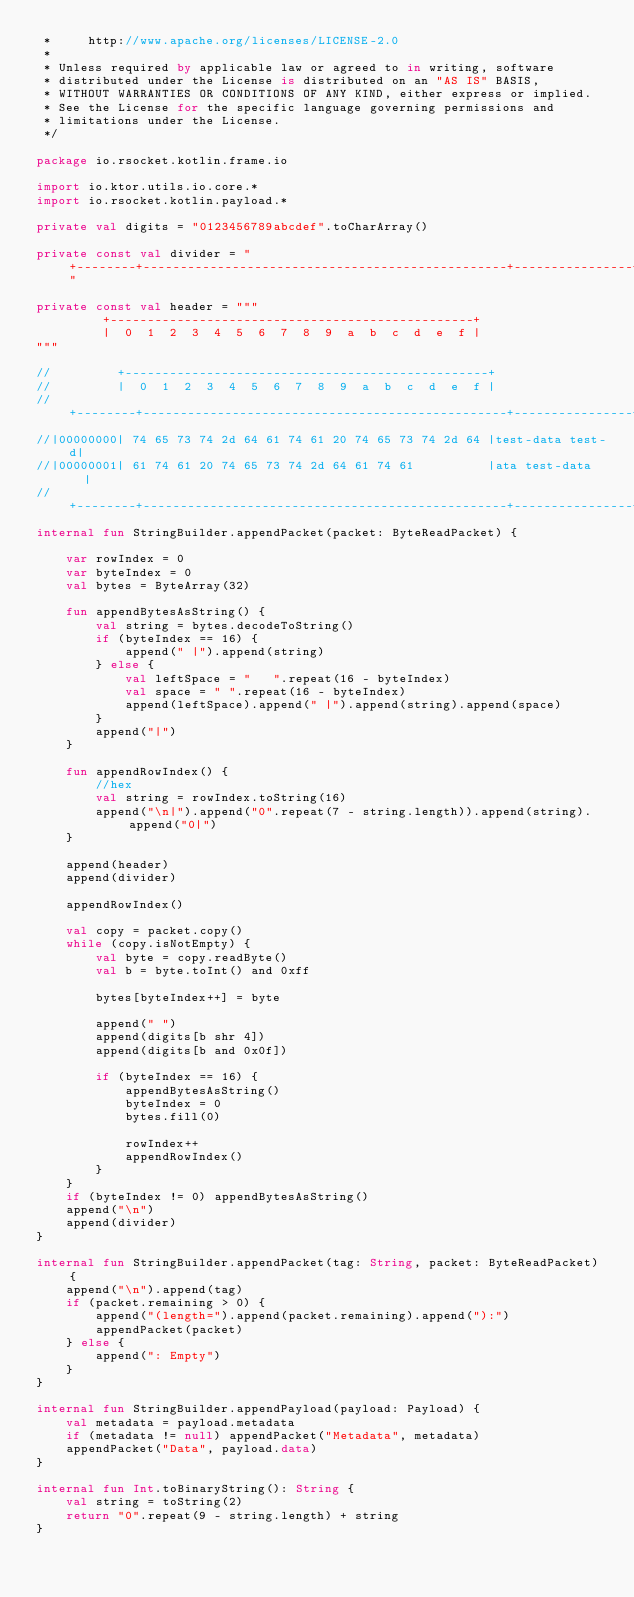Convert code to text. <code><loc_0><loc_0><loc_500><loc_500><_Kotlin_> *     http://www.apache.org/licenses/LICENSE-2.0
 *
 * Unless required by applicable law or agreed to in writing, software
 * distributed under the License is distributed on an "AS IS" BASIS,
 * WITHOUT WARRANTIES OR CONDITIONS OF ANY KIND, either express or implied.
 * See the License for the specific language governing permissions and
 * limitations under the License.
 */

package io.rsocket.kotlin.frame.io

import io.ktor.utils.io.core.*
import io.rsocket.kotlin.payload.*

private val digits = "0123456789abcdef".toCharArray()

private const val divider = "+--------+-------------------------------------------------+----------------+"

private const val header = """
         +-------------------------------------------------+
         |  0  1  2  3  4  5  6  7  8  9  a  b  c  d  e  f |
"""

//         +-------------------------------------------------+
//         |  0  1  2  3  4  5  6  7  8  9  a  b  c  d  e  f |
//+--------+-------------------------------------------------+----------------+
//|00000000| 74 65 73 74 2d 64 61 74 61 20 74 65 73 74 2d 64 |test-data test-d|
//|00000001| 61 74 61 20 74 65 73 74 2d 64 61 74 61          |ata test-data   |
//+--------+-------------------------------------------------+----------------+
internal fun StringBuilder.appendPacket(packet: ByteReadPacket) {

    var rowIndex = 0
    var byteIndex = 0
    val bytes = ByteArray(32)

    fun appendBytesAsString() {
        val string = bytes.decodeToString()
        if (byteIndex == 16) {
            append(" |").append(string)
        } else {
            val leftSpace = "   ".repeat(16 - byteIndex)
            val space = " ".repeat(16 - byteIndex)
            append(leftSpace).append(" |").append(string).append(space)
        }
        append("|")
    }

    fun appendRowIndex() {
        //hex
        val string = rowIndex.toString(16)
        append("\n|").append("0".repeat(7 - string.length)).append(string).append("0|")
    }

    append(header)
    append(divider)

    appendRowIndex()

    val copy = packet.copy()
    while (copy.isNotEmpty) {
        val byte = copy.readByte()
        val b = byte.toInt() and 0xff

        bytes[byteIndex++] = byte

        append(" ")
        append(digits[b shr 4])
        append(digits[b and 0x0f])

        if (byteIndex == 16) {
            appendBytesAsString()
            byteIndex = 0
            bytes.fill(0)

            rowIndex++
            appendRowIndex()
        }
    }
    if (byteIndex != 0) appendBytesAsString()
    append("\n")
    append(divider)
}

internal fun StringBuilder.appendPacket(tag: String, packet: ByteReadPacket) {
    append("\n").append(tag)
    if (packet.remaining > 0) {
        append("(length=").append(packet.remaining).append("):")
        appendPacket(packet)
    } else {
        append(": Empty")
    }
}

internal fun StringBuilder.appendPayload(payload: Payload) {
    val metadata = payload.metadata
    if (metadata != null) appendPacket("Metadata", metadata)
    appendPacket("Data", payload.data)
}

internal fun Int.toBinaryString(): String {
    val string = toString(2)
    return "0".repeat(9 - string.length) + string
}
</code> 